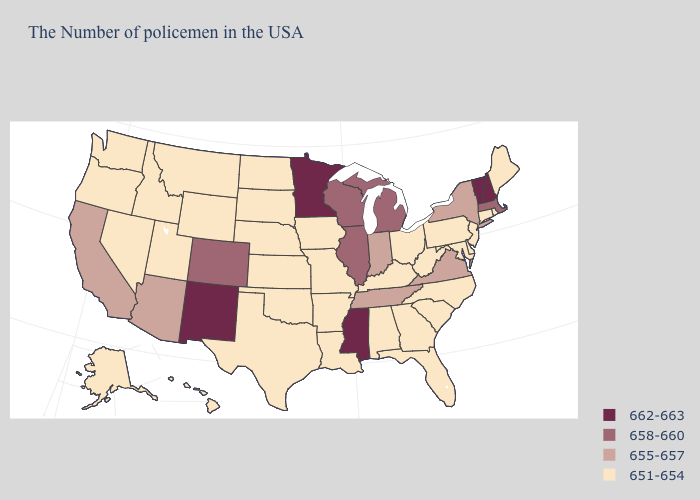Which states have the highest value in the USA?
Answer briefly. New Hampshire, Vermont, Mississippi, Minnesota, New Mexico. Does Nebraska have the lowest value in the USA?
Concise answer only. Yes. Among the states that border Vermont , which have the highest value?
Be succinct. New Hampshire. Name the states that have a value in the range 658-660?
Quick response, please. Massachusetts, Michigan, Wisconsin, Illinois, Colorado. What is the value of South Dakota?
Give a very brief answer. 651-654. Name the states that have a value in the range 651-654?
Answer briefly. Maine, Rhode Island, Connecticut, New Jersey, Delaware, Maryland, Pennsylvania, North Carolina, South Carolina, West Virginia, Ohio, Florida, Georgia, Kentucky, Alabama, Louisiana, Missouri, Arkansas, Iowa, Kansas, Nebraska, Oklahoma, Texas, South Dakota, North Dakota, Wyoming, Utah, Montana, Idaho, Nevada, Washington, Oregon, Alaska, Hawaii. Which states have the lowest value in the Northeast?
Keep it brief. Maine, Rhode Island, Connecticut, New Jersey, Pennsylvania. What is the value of South Carolina?
Be succinct. 651-654. Among the states that border Alabama , which have the lowest value?
Answer briefly. Florida, Georgia. What is the value of Washington?
Write a very short answer. 651-654. What is the value of Kentucky?
Give a very brief answer. 651-654. Among the states that border Massachusetts , does Rhode Island have the highest value?
Write a very short answer. No. What is the highest value in the USA?
Short answer required. 662-663. Does South Carolina have the same value as Wyoming?
Keep it brief. Yes. What is the lowest value in states that border Alabama?
Give a very brief answer. 651-654. 